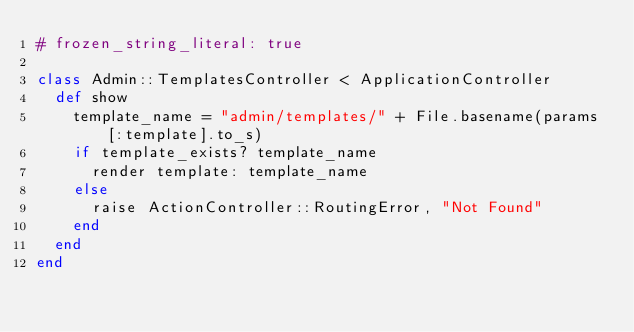Convert code to text. <code><loc_0><loc_0><loc_500><loc_500><_Ruby_># frozen_string_literal: true

class Admin::TemplatesController < ApplicationController
  def show
    template_name = "admin/templates/" + File.basename(params[:template].to_s)
    if template_exists? template_name
      render template: template_name
    else
      raise ActionController::RoutingError, "Not Found"
    end
  end
end
</code> 